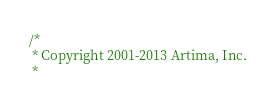Convert code to text. <code><loc_0><loc_0><loc_500><loc_500><_Scala_>/*
 * Copyright 2001-2013 Artima, Inc.
 *</code> 